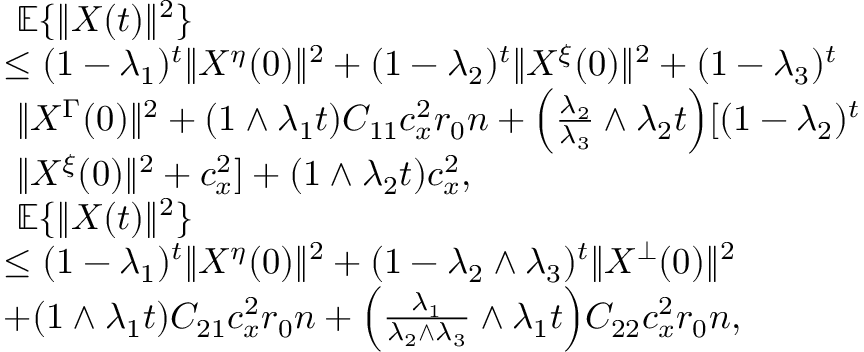<formula> <loc_0><loc_0><loc_500><loc_500>\begin{array} { r l } & { \mathbb { E } \{ \| X ( t ) \| ^ { 2 } \} } \\ & { \leq ( 1 - \lambda _ { 1 } ) ^ { t } \| X ^ { \eta } ( 0 ) \| ^ { 2 } + ( 1 - \lambda _ { 2 } ) ^ { t } \| X ^ { \xi } ( 0 ) \| ^ { 2 } + ( 1 - \lambda _ { 3 } ) ^ { t } } \\ & { \| X ^ { \Gamma } ( 0 ) \| ^ { 2 } + ( 1 \wedge \lambda _ { 1 } t ) C _ { 1 1 } c _ { x } ^ { 2 } r _ { 0 } n + \left ( \frac { \lambda _ { 2 } } { \lambda _ { 3 } } \wedge \lambda _ { 2 } t \right ) [ ( 1 - \lambda _ { 2 } ) ^ { t } } \\ & { \| X ^ { \xi } ( 0 ) \| ^ { 2 } + c _ { x } ^ { 2 } ] + ( 1 \wedge \lambda _ { 2 } t ) c _ { x } ^ { 2 } , } \\ & { \mathbb { E } \{ \| X ( t ) \| ^ { 2 } \} } \\ & { \leq ( 1 - \lambda _ { 1 } ) ^ { t } \| X ^ { \eta } ( 0 ) \| ^ { 2 } + ( 1 - \lambda _ { 2 } \wedge \lambda _ { 3 } ) ^ { t } \| X ^ { \bot } ( 0 ) \| ^ { 2 } } \\ & { + ( 1 \wedge \lambda _ { 1 } t ) C _ { 2 1 } c _ { x } ^ { 2 } r _ { 0 } n + \left ( \frac { \lambda _ { 1 } } { \lambda _ { 2 } \wedge \lambda _ { 3 } } \wedge \lambda _ { 1 } t \right ) C _ { 2 2 } c _ { x } ^ { 2 } r _ { 0 } n , } \end{array}</formula> 